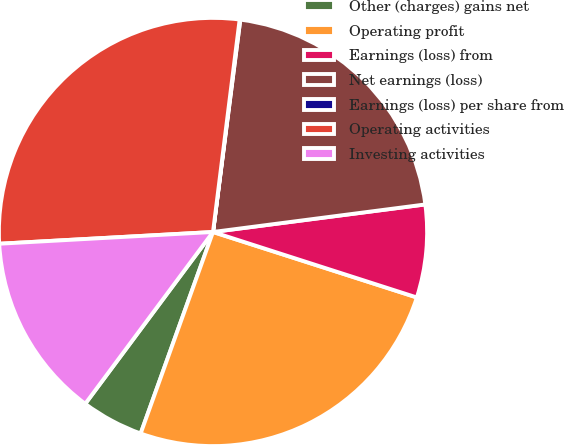<chart> <loc_0><loc_0><loc_500><loc_500><pie_chart><fcel>Other (charges) gains net<fcel>Operating profit<fcel>Earnings (loss) from<fcel>Net earnings (loss)<fcel>Earnings (loss) per share from<fcel>Operating activities<fcel>Investing activities<nl><fcel>4.69%<fcel>25.54%<fcel>7.0%<fcel>20.91%<fcel>0.05%<fcel>27.86%<fcel>13.95%<nl></chart> 